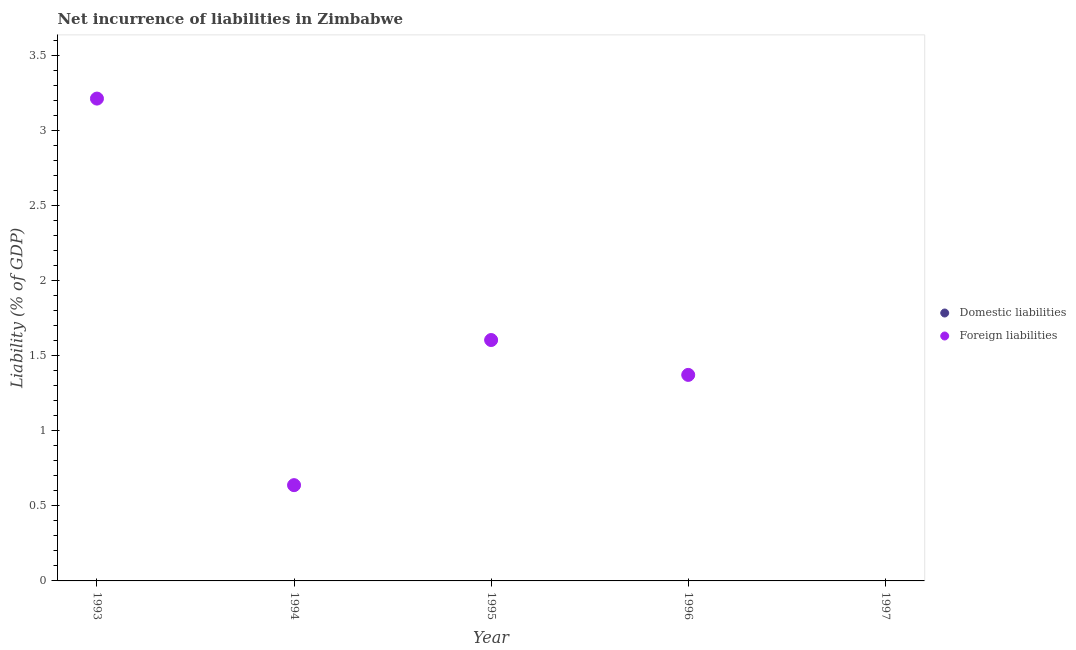What is the incurrence of domestic liabilities in 1997?
Provide a succinct answer. 0. Across all years, what is the maximum incurrence of foreign liabilities?
Make the answer very short. 3.22. What is the total incurrence of foreign liabilities in the graph?
Make the answer very short. 6.83. What is the difference between the incurrence of foreign liabilities in 1993 and that in 1994?
Keep it short and to the point. 2.58. What is the difference between the incurrence of foreign liabilities in 1994 and the incurrence of domestic liabilities in 1993?
Offer a terse response. 0.64. What is the average incurrence of foreign liabilities per year?
Make the answer very short. 1.37. What is the ratio of the incurrence of foreign liabilities in 1994 to that in 1996?
Your answer should be compact. 0.46. What is the difference between the highest and the second highest incurrence of foreign liabilities?
Offer a terse response. 1.61. What is the difference between the highest and the lowest incurrence of foreign liabilities?
Your answer should be compact. 3.22. Is the incurrence of domestic liabilities strictly less than the incurrence of foreign liabilities over the years?
Make the answer very short. Yes. How many years are there in the graph?
Ensure brevity in your answer.  5. Does the graph contain any zero values?
Give a very brief answer. Yes. Does the graph contain grids?
Your answer should be compact. No. Where does the legend appear in the graph?
Ensure brevity in your answer.  Center right. How many legend labels are there?
Offer a terse response. 2. How are the legend labels stacked?
Your response must be concise. Vertical. What is the title of the graph?
Keep it short and to the point. Net incurrence of liabilities in Zimbabwe. Does "Researchers" appear as one of the legend labels in the graph?
Offer a very short reply. No. What is the label or title of the Y-axis?
Give a very brief answer. Liability (% of GDP). What is the Liability (% of GDP) of Domestic liabilities in 1993?
Your response must be concise. 0. What is the Liability (% of GDP) of Foreign liabilities in 1993?
Offer a very short reply. 3.22. What is the Liability (% of GDP) of Foreign liabilities in 1994?
Your answer should be compact. 0.64. What is the Liability (% of GDP) of Domestic liabilities in 1995?
Provide a succinct answer. 0. What is the Liability (% of GDP) in Foreign liabilities in 1995?
Your answer should be very brief. 1.61. What is the Liability (% of GDP) in Domestic liabilities in 1996?
Provide a succinct answer. 0. What is the Liability (% of GDP) of Foreign liabilities in 1996?
Make the answer very short. 1.37. Across all years, what is the maximum Liability (% of GDP) in Foreign liabilities?
Provide a short and direct response. 3.22. Across all years, what is the minimum Liability (% of GDP) in Foreign liabilities?
Offer a terse response. 0. What is the total Liability (% of GDP) in Foreign liabilities in the graph?
Offer a very short reply. 6.83. What is the difference between the Liability (% of GDP) of Foreign liabilities in 1993 and that in 1994?
Ensure brevity in your answer.  2.58. What is the difference between the Liability (% of GDP) in Foreign liabilities in 1993 and that in 1995?
Your answer should be compact. 1.61. What is the difference between the Liability (% of GDP) in Foreign liabilities in 1993 and that in 1996?
Provide a succinct answer. 1.84. What is the difference between the Liability (% of GDP) in Foreign liabilities in 1994 and that in 1995?
Give a very brief answer. -0.97. What is the difference between the Liability (% of GDP) in Foreign liabilities in 1994 and that in 1996?
Provide a short and direct response. -0.73. What is the difference between the Liability (% of GDP) of Foreign liabilities in 1995 and that in 1996?
Make the answer very short. 0.23. What is the average Liability (% of GDP) in Domestic liabilities per year?
Your response must be concise. 0. What is the average Liability (% of GDP) of Foreign liabilities per year?
Give a very brief answer. 1.37. What is the ratio of the Liability (% of GDP) of Foreign liabilities in 1993 to that in 1994?
Provide a succinct answer. 5.04. What is the ratio of the Liability (% of GDP) of Foreign liabilities in 1993 to that in 1995?
Your answer should be compact. 2. What is the ratio of the Liability (% of GDP) of Foreign liabilities in 1993 to that in 1996?
Keep it short and to the point. 2.34. What is the ratio of the Liability (% of GDP) of Foreign liabilities in 1994 to that in 1995?
Your answer should be very brief. 0.4. What is the ratio of the Liability (% of GDP) in Foreign liabilities in 1994 to that in 1996?
Give a very brief answer. 0.46. What is the ratio of the Liability (% of GDP) in Foreign liabilities in 1995 to that in 1996?
Offer a very short reply. 1.17. What is the difference between the highest and the second highest Liability (% of GDP) in Foreign liabilities?
Keep it short and to the point. 1.61. What is the difference between the highest and the lowest Liability (% of GDP) in Foreign liabilities?
Give a very brief answer. 3.22. 